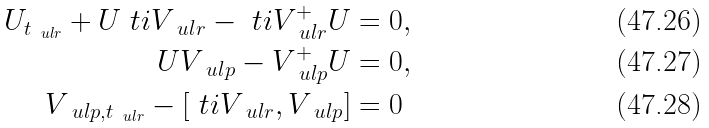<formula> <loc_0><loc_0><loc_500><loc_500>U _ { t _ { \ u l r } } + U \ t i { V } _ { \ u l r } - \ t i V _ { \ u l r } ^ { + } U & = 0 , \\ U V _ { \ u l p } - V ^ { + } _ { \ u l p } U & = 0 , \\ V _ { \ u l p , t _ { \ u l r } } - \left [ \ t i V _ { \ u l r } , V _ { \ u l p } \right ] & = 0</formula> 